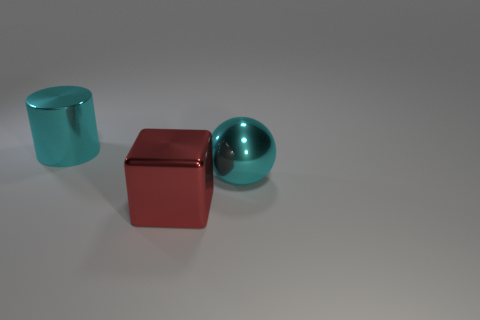Add 1 shiny objects. How many objects exist? 4 Subtract all blocks. How many objects are left? 2 Add 3 big metal spheres. How many big metal spheres are left? 4 Add 2 large shiny balls. How many large shiny balls exist? 3 Subtract 0 purple cylinders. How many objects are left? 3 Subtract all large brown metallic objects. Subtract all shiny balls. How many objects are left? 2 